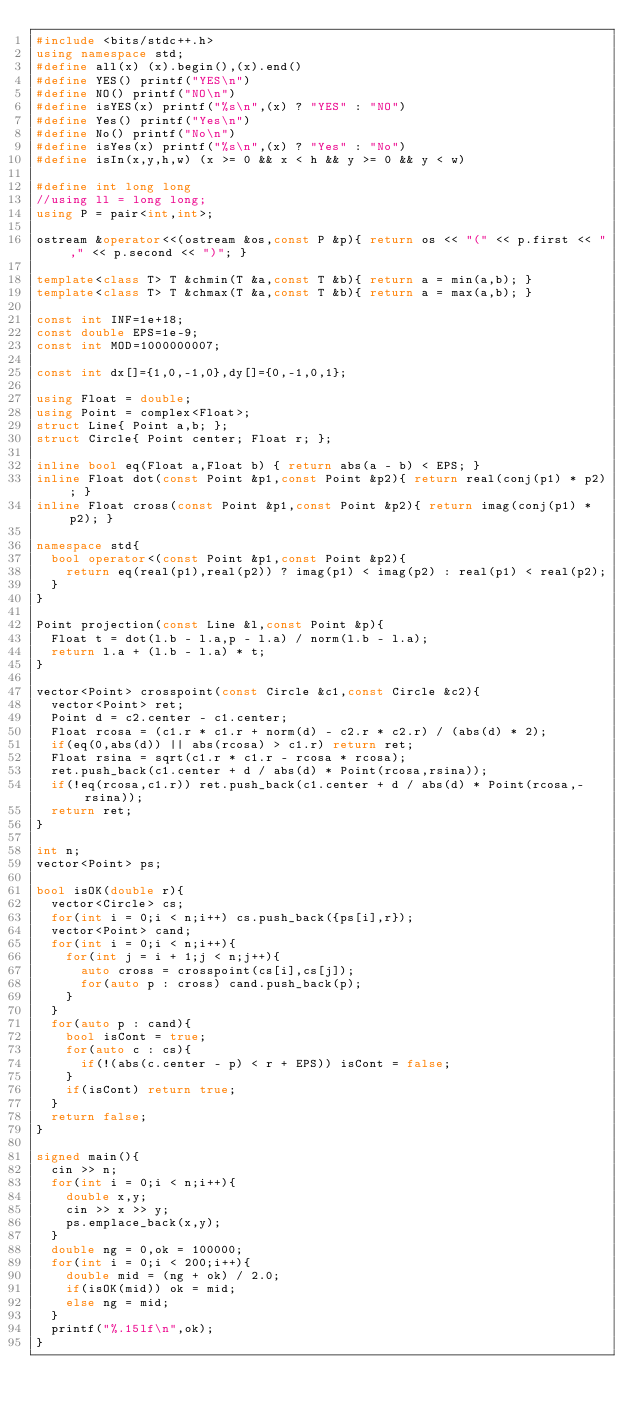Convert code to text. <code><loc_0><loc_0><loc_500><loc_500><_C++_>#include <bits/stdc++.h>
using namespace std;
#define all(x) (x).begin(),(x).end()
#define YES() printf("YES\n")
#define NO() printf("NO\n")
#define isYES(x) printf("%s\n",(x) ? "YES" : "NO")
#define Yes() printf("Yes\n")
#define No() printf("No\n")
#define isYes(x) printf("%s\n",(x) ? "Yes" : "No")
#define isIn(x,y,h,w) (x >= 0 && x < h && y >= 0 && y < w)

#define int long long
//using ll = long long;
using P = pair<int,int>;

ostream &operator<<(ostream &os,const P &p){ return os << "(" << p.first << "," << p.second << ")"; }

template<class T> T &chmin(T &a,const T &b){ return a = min(a,b); }
template<class T> T &chmax(T &a,const T &b){ return a = max(a,b); }
 
const int INF=1e+18;
const double EPS=1e-9;
const int MOD=1000000007;

const int dx[]={1,0,-1,0},dy[]={0,-1,0,1};

using Float = double;
using Point = complex<Float>;
struct Line{ Point a,b; };
struct Circle{ Point center; Float r; };

inline bool eq(Float a,Float b) { return abs(a - b) < EPS; }
inline Float dot(const Point &p1,const Point &p2){ return real(conj(p1) * p2); }
inline Float cross(const Point &p1,const Point &p2){ return imag(conj(p1) * p2); }

namespace std{
	bool operator<(const Point &p1,const Point &p2){
		return eq(real(p1),real(p2)) ? imag(p1) < imag(p2) : real(p1) < real(p2);
	}
}

Point projection(const Line &l,const Point &p){
	Float t = dot(l.b - l.a,p - l.a) / norm(l.b - l.a);
	return l.a + (l.b - l.a) * t;
}

vector<Point> crosspoint(const Circle &c1,const Circle &c2){
	vector<Point> ret;
	Point d = c2.center - c1.center;
	Float rcosa = (c1.r * c1.r + norm(d) - c2.r * c2.r) / (abs(d) * 2);
	if(eq(0,abs(d)) || abs(rcosa) > c1.r) return ret;
	Float rsina = sqrt(c1.r * c1.r - rcosa * rcosa);
	ret.push_back(c1.center + d / abs(d) * Point(rcosa,rsina));
	if(!eq(rcosa,c1.r)) ret.push_back(c1.center + d / abs(d) * Point(rcosa,-rsina));
	return ret;
}

int n;
vector<Point> ps;

bool isOK(double r){
	vector<Circle> cs;
	for(int i = 0;i < n;i++) cs.push_back({ps[i],r});
	vector<Point> cand;
	for(int i = 0;i < n;i++){
		for(int j = i + 1;j < n;j++){
			auto cross = crosspoint(cs[i],cs[j]);
			for(auto p : cross) cand.push_back(p);
		}
	}
	for(auto p : cand){
		bool isCont = true;
		for(auto c : cs){
			if(!(abs(c.center - p) < r + EPS)) isCont = false;
		}
		if(isCont) return true;
	}
	return false;
}

signed main(){
	cin >> n;
	for(int i = 0;i < n;i++){
		double x,y;
		cin >> x >> y;
		ps.emplace_back(x,y);
	}
	double ng = 0,ok = 100000;
	for(int i = 0;i < 200;i++){
		double mid = (ng + ok) / 2.0;
		if(isOK(mid)) ok = mid;
		else ng = mid;
	}
	printf("%.15lf\n",ok);
}
</code> 